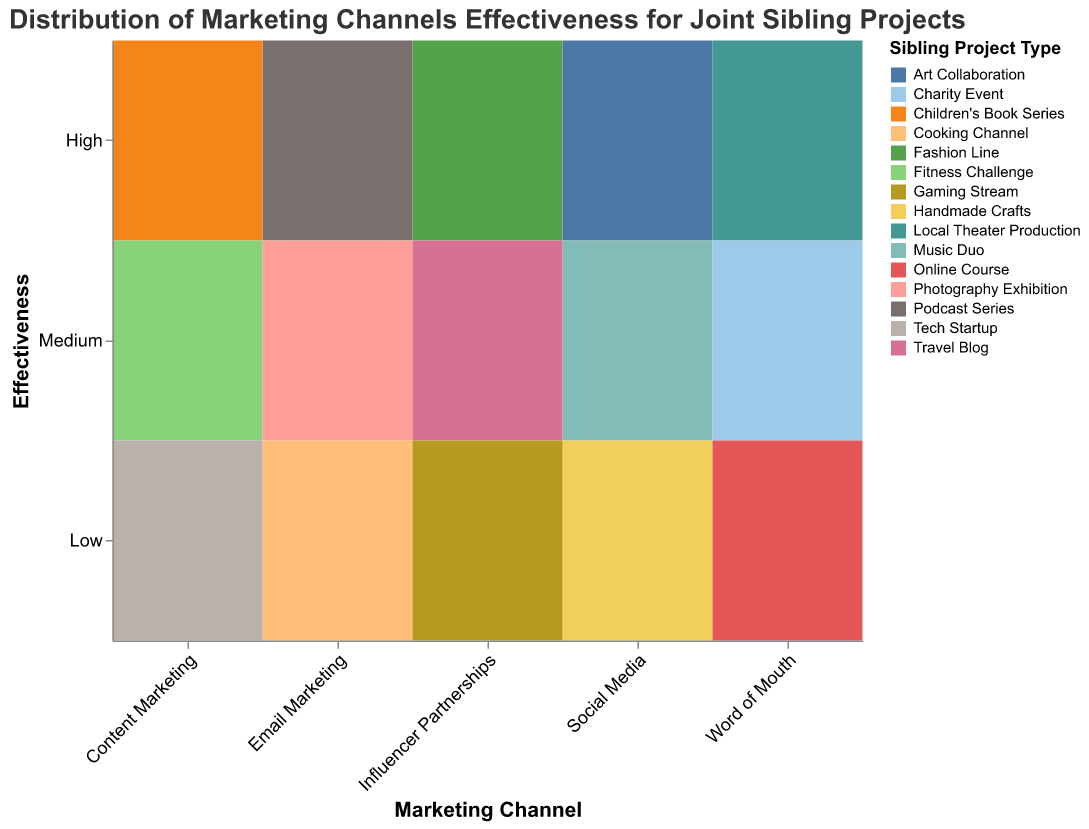What is the title of the figure? The title is usually positioned at the top of the figure and provides the overall context of the data being displayed. In this case, it indicates what the figure is about.
Answer: Distribution of Marketing Channels Effectiveness for Joint Sibling Projects Which marketing channel has the highest effectiveness rating for the "Children's Book Series" project? Check the "High" row on the Y-axis and locate the corresponding cell for the "Content Marketing" column on the X-axis. The color legend indicates "Children's Book Series".
Answer: Content Marketing How many project types are shown for the "Word of Mouth" marketing channel? Look at the X-axis for "Word of Mouth" and count the number of different colored rectangles within this column. Each color represents a different project type according to the legend.
Answer: 3 Which sibling project type is associated with the lowest effectiveness in "Email Marketing"? Check the "Low" row on the Y-axis and locate the cell in the "Email Marketing" column on the X-axis. Refer to the color coded rectangle and the legend to identify the project type.
Answer: Cooking Channel Compare the effectiveness of "Social Media" and "Influencer Partnerships" for the "Medium" effectiveness rating. Which project types are associated with each? Check the "Medium" row on the Y-axis and locate the cells in the "Social Media" and "Influencer Partnerships" columns on the X-axis. Use the color legend to identify the project types.
Answer: Music Duo, Travel Blog Which marketing channel appears to have the most diverse effectiveness ratings across different project types? To answer this, check how many different rows (effectiveness ratings) and columns (project types) a specific marketing channel covers.
Answer: Influencer Partnerships Identify the marketing channel that supports a "Tech Startup" project. What is its effectiveness rating? Look for the "Tech Startup" project type in the color legend and locate its position in the corresponding marketing channel and effectiveness cell.
Answer: Content Marketing, Low For the "Podcast Series", what is the marketing channel and its effectiveness rating? Use the color legend to find the "Podcast Series" project and then locate this project within the corresponding row and column.
Answer: Email Marketing, High Which marketing channel has a higher representation of low effectiveness ratings? Identify the marketing channels by counting the number of "Low" effectiveness ratings associated with each. The channel with the highest count has the higher representation.
Answer: Social Media If you sum the number of projects rated "High" across all marketing channels, what is the total count? Count each "High" effectiveness rating row for all marketing channels and sum them up.
Answer: 5 